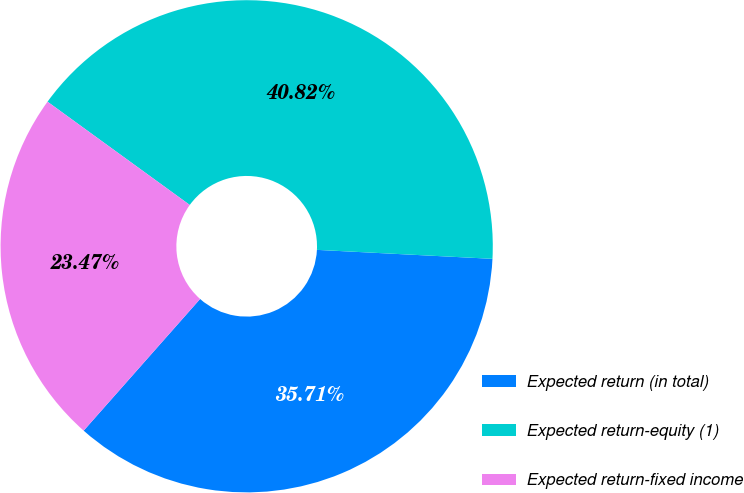<chart> <loc_0><loc_0><loc_500><loc_500><pie_chart><fcel>Expected return (in total)<fcel>Expected return-equity (1)<fcel>Expected return-fixed income<nl><fcel>35.71%<fcel>40.82%<fcel>23.47%<nl></chart> 